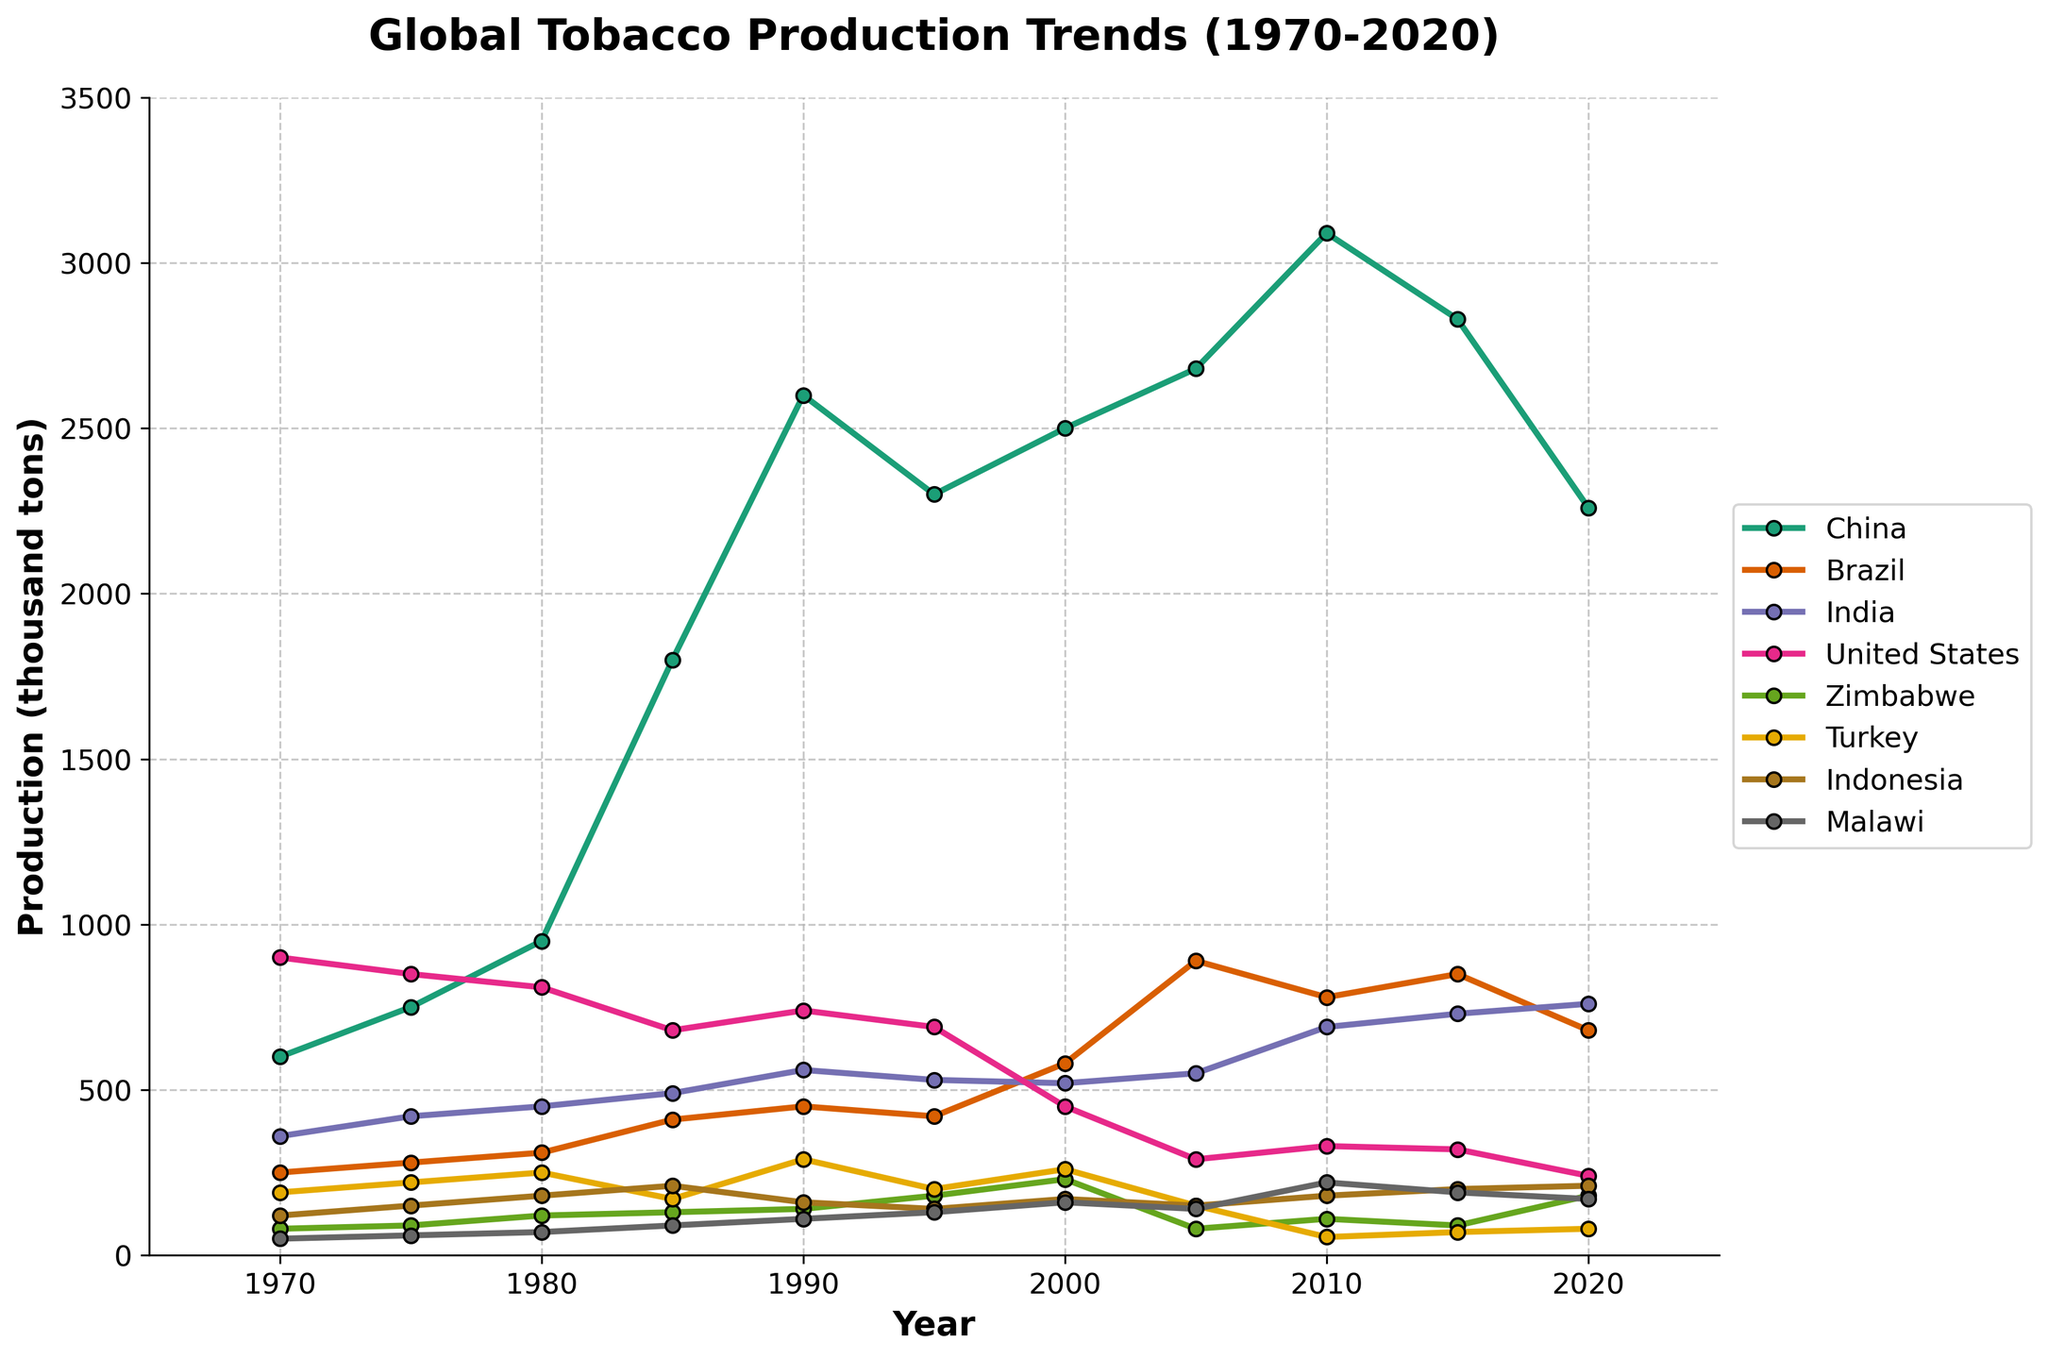What was the trend of tobacco production in China between 1970 and 2020? To determine the trend, look at the trajectory of China's tobacco production line. It starts at 600 thousand tons in 1970, rises significantly, peaking at 3090 in 2010, then declines to 2260 in 2020. Overall, the trend is an increase followed by a decrease.
Answer: Increased until 2010, then decreased In which year did the United States have its lowest tobacco production, and how much was it? Identify the lowest point on the United States' tobacco production line. The lowest production is in 2020 at 240 thousand tons.
Answer: 2020, 240 thousand tons How does Brazil's tobacco production in 2000 compare to that in 2010? Compare the values on Brazil's line for the years 2000 and 2010. In 2000, Brazil's production was 580 thousand tons, and in 2010, it was 780 thousand tons. This shows an increase.
Answer: Increased Which country had the most significant increase in tobacco production between 1975 and 1985? To find this, subtract the 1975 production values from the 1985 production values for each country. Compare the differences. China had the most significant increase: 1800 - 750 = 1050 thousand tons.
Answer: China How did Malawi's tobacco production in 2010 compare to that in 1990, and by how much did it change? Compare Malawi's tobacco production in 2010 (220 thousand tons) to 1990 (110 thousand tons). Subtract to find the change: 220 - 110 = 110 thousand tons increase.
Answer: Increased by 110 thousand tons What is the average tobacco production in India across all the years depicted in the chart? Sum the production values for India from all years and divide by the number of years. (360+420+450+490+560+530+520+550+690+730+760) = 5460. There are 11 years, so 5460 / 11 = 496.36 thousand tons.
Answer: 496.36 thousand tons Which country had a more stable production level: Zimbabwe or Turkey? Observe the fluctuations in the production lines of Zimbabwe and Turkey. Zimbabwe's line has relatively more erratic rises and falls compared to Turkey's more stable line, especially after 1985.
Answer: Turkey What was the combined tobacco production of China, Brazil, and the United States in 1980? Add the production values of China (950 thousand tons), Brazil (310 thousand tons), and the United States (810 thousand tons) for 1980. 950 + 310 + 810 = 2070 thousand tons.
Answer: 2070 thousand tons By how much did Indonesia's tobacco production change from its highest point to its lowest point? Identify the highest point (2020 with 210 thousand tons) and the lowest point (1970 with 120 thousand tons) for Indonesia. Subtract the lowest point from the highest point: 210 - 120 = 90 thousand tons.
Answer: 90 thousand tons Which country showed the most fluctuating trend over the 50-year period? Look for the country with the most ups and downs in its production line. The United States' production line shows significant fluctuations, especially with a steep drop after 1980.
Answer: United States 